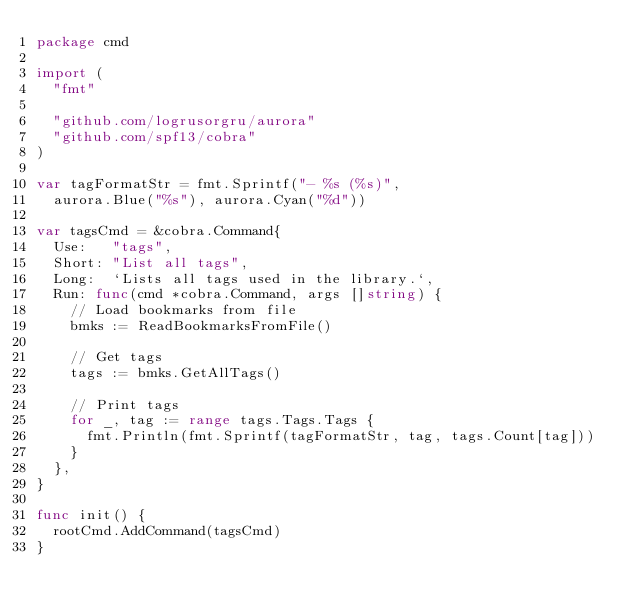<code> <loc_0><loc_0><loc_500><loc_500><_Go_>package cmd

import (
	"fmt"

	"github.com/logrusorgru/aurora"
	"github.com/spf13/cobra"
)

var tagFormatStr = fmt.Sprintf("- %s (%s)",
	aurora.Blue("%s"), aurora.Cyan("%d"))

var tagsCmd = &cobra.Command{
	Use:   "tags",
	Short: "List all tags",
	Long:  `Lists all tags used in the library.`,
	Run: func(cmd *cobra.Command, args []string) {
		// Load bookmarks from file
		bmks := ReadBookmarksFromFile()

		// Get tags
		tags := bmks.GetAllTags()

		// Print tags
		for _, tag := range tags.Tags.Tags {
			fmt.Println(fmt.Sprintf(tagFormatStr, tag, tags.Count[tag]))
		}
	},
}

func init() {
	rootCmd.AddCommand(tagsCmd)
}
</code> 